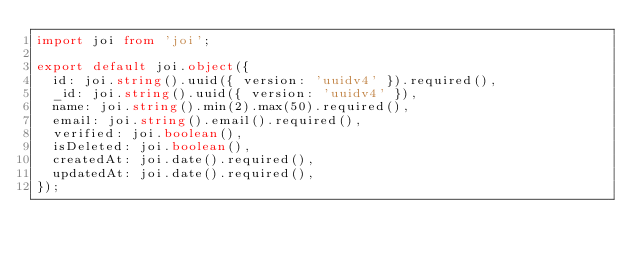<code> <loc_0><loc_0><loc_500><loc_500><_TypeScript_>import joi from 'joi';

export default joi.object({
  id: joi.string().uuid({ version: 'uuidv4' }).required(),
  _id: joi.string().uuid({ version: 'uuidv4' }),
  name: joi.string().min(2).max(50).required(),
  email: joi.string().email().required(),
  verified: joi.boolean(),
  isDeleted: joi.boolean(),
  createdAt: joi.date().required(),
  updatedAt: joi.date().required(),
});
</code> 